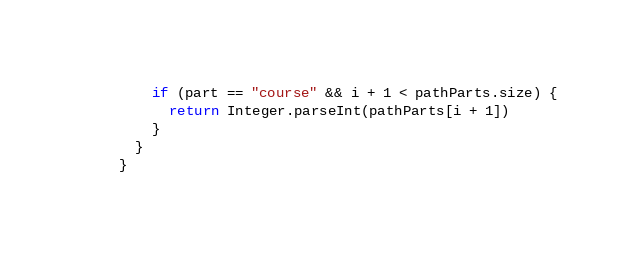<code> <loc_0><loc_0><loc_500><loc_500><_Kotlin_>        if (part == "course" && i + 1 < pathParts.size) {
          return Integer.parseInt(pathParts[i + 1])
        }
      }
    }</code> 